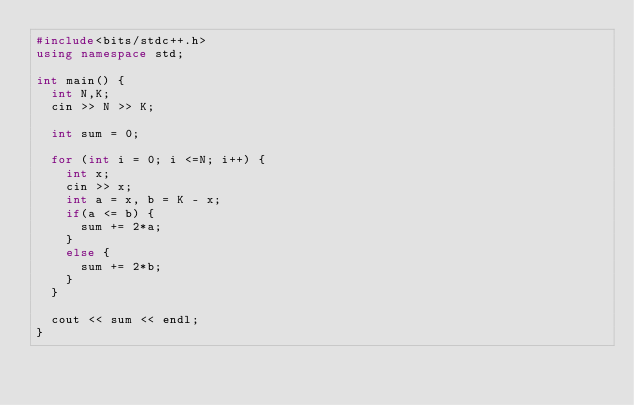<code> <loc_0><loc_0><loc_500><loc_500><_C++_>#include<bits/stdc++.h>
using namespace std;

int main() {
  int N,K;
  cin >> N >> K;
  
  int sum = 0;
  
  for (int i = 0; i <=N; i++) {
    int x;
    cin >> x;
    int a = x, b = K - x;
    if(a <= b) {
      sum += 2*a;
    }
    else {
      sum += 2*b;
    }
  }
  
  cout << sum << endl;
}</code> 